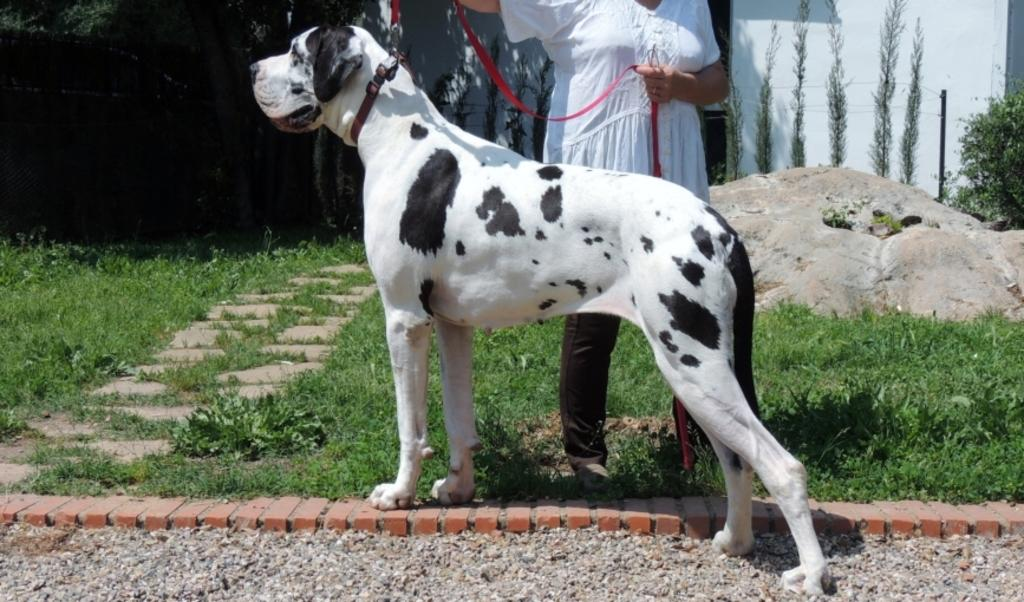What type of animal can be seen in the image? There is a dog in the image. Who is holding the dog leash in the image? There is a person holding a dog leash in the image. What type of terrain is visible in the image? There is grass in the image. What other types of vegetation are present in the image? There are plants in the image. What can be seen in the background of the image? There are trees and a wall in the background of the image. How many rabbits are playing with the goose in the image? There are no rabbits or goose present in the image; it features a dog and a person holding a leash. 